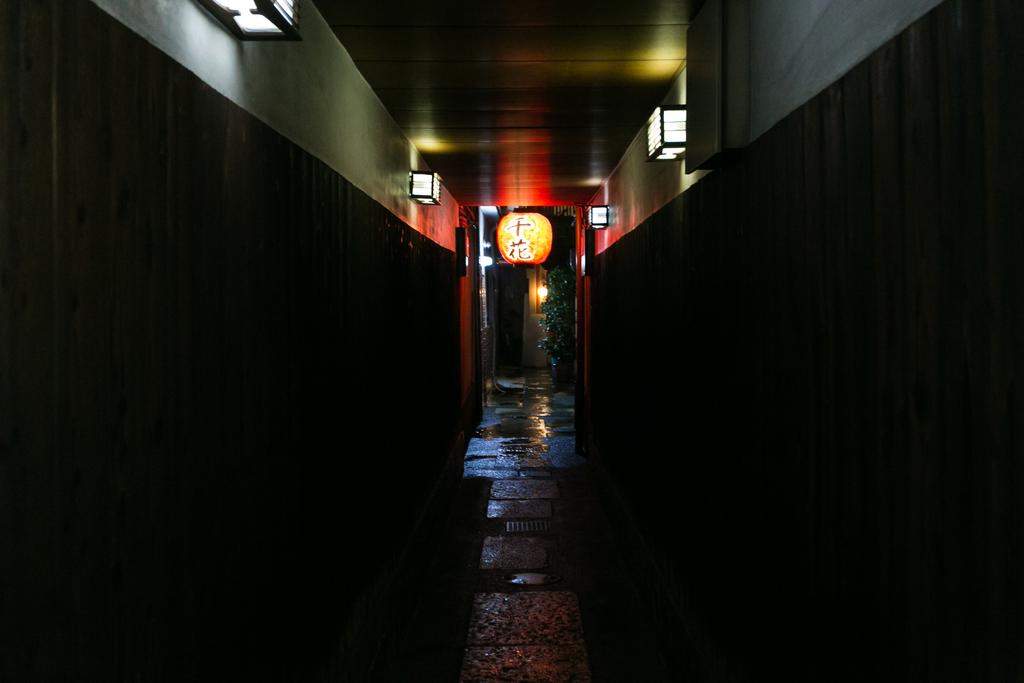What type of surface can be seen in the image? There is ground visible in the image. How many walls are present in the image? There are two walls in the image, one grey and one black. What can be seen illuminating the area in the image? There are lights in the image. What type of lighting fixture is present in the image? There is a lantern in the image. What color is the tree in the image? The tree in the image is green in color. What is covering the ground in the image? There is water on the ground in the image. What type of kettle is being used to cover the tree in the image? There is no kettle present in the image, and the tree is not being covered by any object. What type of mask is being worn by the lantern in the image? There is no mask present in the image, as the lantern is an inanimate object and does not wear masks. 